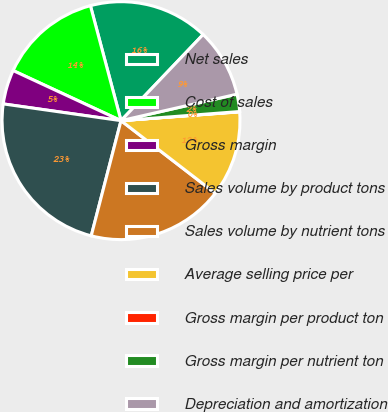<chart> <loc_0><loc_0><loc_500><loc_500><pie_chart><fcel>Net sales<fcel>Cost of sales<fcel>Gross margin<fcel>Sales volume by product tons<fcel>Sales volume by nutrient tons<fcel>Average selling price per<fcel>Gross margin per product ton<fcel>Gross margin per nutrient ton<fcel>Depreciation and amortization<nl><fcel>16.26%<fcel>13.94%<fcel>4.67%<fcel>23.22%<fcel>18.58%<fcel>11.63%<fcel>0.04%<fcel>2.35%<fcel>9.31%<nl></chart> 